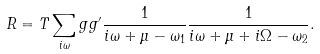<formula> <loc_0><loc_0><loc_500><loc_500>R = T \sum _ { i \omega } g g ^ { \prime } \frac { 1 } { i \omega + \mu - \omega _ { 1 } } \frac { 1 } { i \omega + \mu + i \Omega - \omega _ { 2 } } .</formula> 